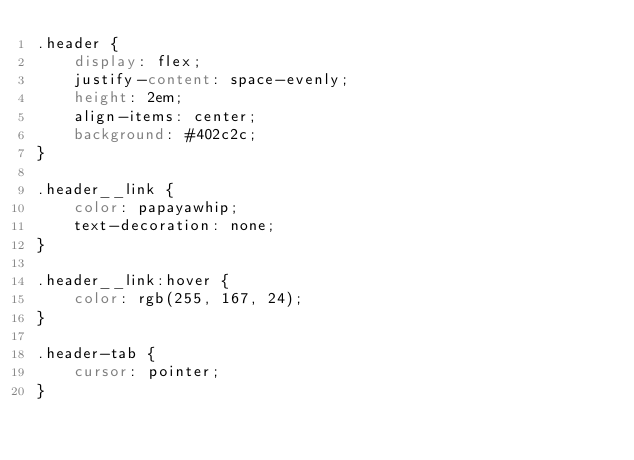Convert code to text. <code><loc_0><loc_0><loc_500><loc_500><_CSS_>.header {
    display: flex;
    justify-content: space-evenly;
    height: 2em;
    align-items: center;
    background: #402c2c;    
}

.header__link {
    color: papayawhip;
    text-decoration: none;
}

.header__link:hover {
    color: rgb(255, 167, 24);
}

.header-tab {
    cursor: pointer;
}</code> 